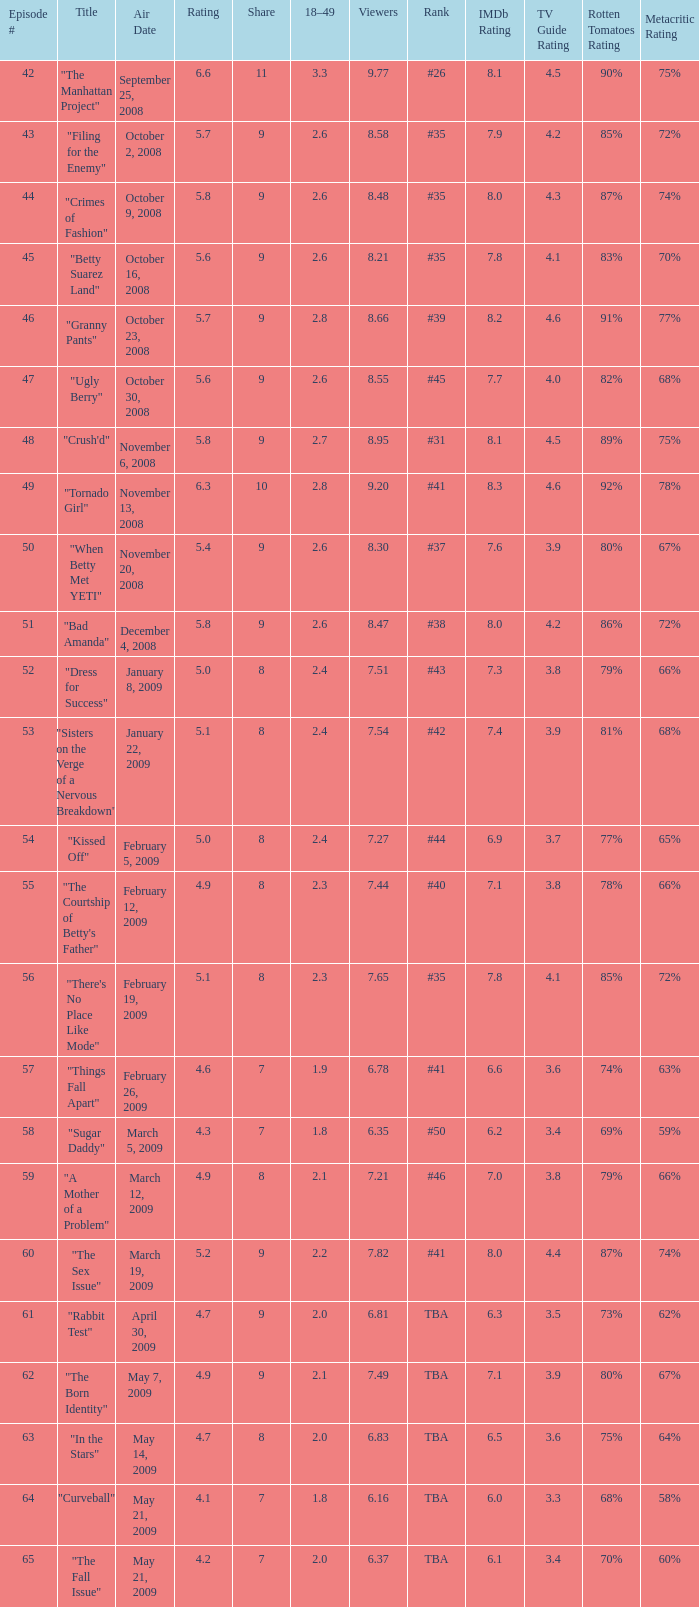What is the average Episode # with a 7 share and 18–49 is less than 2 and the Air Date of may 21, 2009? 64.0. 